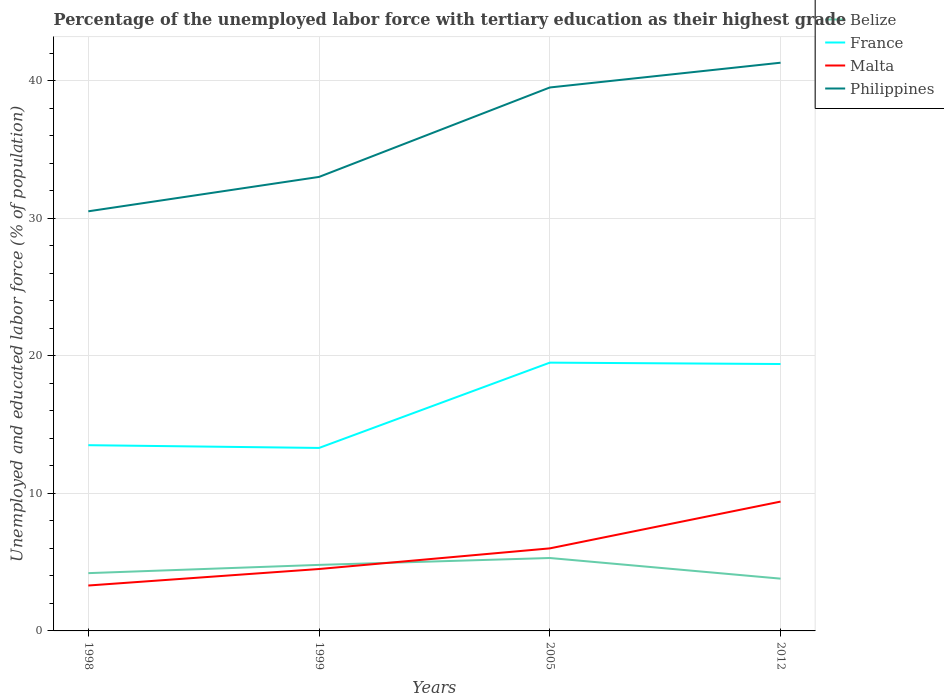Does the line corresponding to Malta intersect with the line corresponding to Belize?
Keep it short and to the point. Yes. Across all years, what is the maximum percentage of the unemployed labor force with tertiary education in Belize?
Ensure brevity in your answer.  3.8. What is the total percentage of the unemployed labor force with tertiary education in Malta in the graph?
Your response must be concise. -1.2. What is the difference between the highest and the second highest percentage of the unemployed labor force with tertiary education in Malta?
Ensure brevity in your answer.  6.1. What is the difference between the highest and the lowest percentage of the unemployed labor force with tertiary education in Philippines?
Provide a succinct answer. 2. How many years are there in the graph?
Give a very brief answer. 4. What is the difference between two consecutive major ticks on the Y-axis?
Your response must be concise. 10. Are the values on the major ticks of Y-axis written in scientific E-notation?
Offer a very short reply. No. Where does the legend appear in the graph?
Your answer should be compact. Top right. How many legend labels are there?
Ensure brevity in your answer.  4. What is the title of the graph?
Keep it short and to the point. Percentage of the unemployed labor force with tertiary education as their highest grade. What is the label or title of the X-axis?
Your answer should be very brief. Years. What is the label or title of the Y-axis?
Provide a succinct answer. Unemployed and educated labor force (% of population). What is the Unemployed and educated labor force (% of population) in Belize in 1998?
Provide a succinct answer. 4.2. What is the Unemployed and educated labor force (% of population) of France in 1998?
Your answer should be very brief. 13.5. What is the Unemployed and educated labor force (% of population) of Malta in 1998?
Keep it short and to the point. 3.3. What is the Unemployed and educated labor force (% of population) in Philippines in 1998?
Provide a short and direct response. 30.5. What is the Unemployed and educated labor force (% of population) in Belize in 1999?
Offer a very short reply. 4.8. What is the Unemployed and educated labor force (% of population) in France in 1999?
Keep it short and to the point. 13.3. What is the Unemployed and educated labor force (% of population) of Malta in 1999?
Your answer should be very brief. 4.5. What is the Unemployed and educated labor force (% of population) of Belize in 2005?
Keep it short and to the point. 5.3. What is the Unemployed and educated labor force (% of population) in Philippines in 2005?
Provide a succinct answer. 39.5. What is the Unemployed and educated labor force (% of population) of Belize in 2012?
Ensure brevity in your answer.  3.8. What is the Unemployed and educated labor force (% of population) of France in 2012?
Ensure brevity in your answer.  19.4. What is the Unemployed and educated labor force (% of population) in Malta in 2012?
Provide a short and direct response. 9.4. What is the Unemployed and educated labor force (% of population) of Philippines in 2012?
Ensure brevity in your answer.  41.3. Across all years, what is the maximum Unemployed and educated labor force (% of population) of Belize?
Provide a succinct answer. 5.3. Across all years, what is the maximum Unemployed and educated labor force (% of population) of France?
Give a very brief answer. 19.5. Across all years, what is the maximum Unemployed and educated labor force (% of population) in Malta?
Your response must be concise. 9.4. Across all years, what is the maximum Unemployed and educated labor force (% of population) in Philippines?
Offer a very short reply. 41.3. Across all years, what is the minimum Unemployed and educated labor force (% of population) in Belize?
Ensure brevity in your answer.  3.8. Across all years, what is the minimum Unemployed and educated labor force (% of population) of France?
Ensure brevity in your answer.  13.3. Across all years, what is the minimum Unemployed and educated labor force (% of population) in Malta?
Your response must be concise. 3.3. Across all years, what is the minimum Unemployed and educated labor force (% of population) of Philippines?
Offer a terse response. 30.5. What is the total Unemployed and educated labor force (% of population) of France in the graph?
Your answer should be very brief. 65.7. What is the total Unemployed and educated labor force (% of population) in Malta in the graph?
Ensure brevity in your answer.  23.2. What is the total Unemployed and educated labor force (% of population) in Philippines in the graph?
Your response must be concise. 144.3. What is the difference between the Unemployed and educated labor force (% of population) of France in 1998 and that in 1999?
Provide a succinct answer. 0.2. What is the difference between the Unemployed and educated labor force (% of population) of Belize in 1998 and that in 2005?
Keep it short and to the point. -1.1. What is the difference between the Unemployed and educated labor force (% of population) of France in 1998 and that in 2005?
Provide a short and direct response. -6. What is the difference between the Unemployed and educated labor force (% of population) of Philippines in 1998 and that in 2005?
Provide a succinct answer. -9. What is the difference between the Unemployed and educated labor force (% of population) of France in 1998 and that in 2012?
Offer a very short reply. -5.9. What is the difference between the Unemployed and educated labor force (% of population) in Belize in 1999 and that in 2005?
Give a very brief answer. -0.5. What is the difference between the Unemployed and educated labor force (% of population) of Malta in 1999 and that in 2005?
Offer a terse response. -1.5. What is the difference between the Unemployed and educated labor force (% of population) of Philippines in 1999 and that in 2005?
Your response must be concise. -6.5. What is the difference between the Unemployed and educated labor force (% of population) in France in 1999 and that in 2012?
Provide a succinct answer. -6.1. What is the difference between the Unemployed and educated labor force (% of population) in Belize in 2005 and that in 2012?
Your response must be concise. 1.5. What is the difference between the Unemployed and educated labor force (% of population) of France in 2005 and that in 2012?
Offer a very short reply. 0.1. What is the difference between the Unemployed and educated labor force (% of population) of Belize in 1998 and the Unemployed and educated labor force (% of population) of Philippines in 1999?
Your response must be concise. -28.8. What is the difference between the Unemployed and educated labor force (% of population) of France in 1998 and the Unemployed and educated labor force (% of population) of Philippines in 1999?
Ensure brevity in your answer.  -19.5. What is the difference between the Unemployed and educated labor force (% of population) of Malta in 1998 and the Unemployed and educated labor force (% of population) of Philippines in 1999?
Your answer should be very brief. -29.7. What is the difference between the Unemployed and educated labor force (% of population) of Belize in 1998 and the Unemployed and educated labor force (% of population) of France in 2005?
Your answer should be very brief. -15.3. What is the difference between the Unemployed and educated labor force (% of population) of Belize in 1998 and the Unemployed and educated labor force (% of population) of Philippines in 2005?
Give a very brief answer. -35.3. What is the difference between the Unemployed and educated labor force (% of population) in France in 1998 and the Unemployed and educated labor force (% of population) in Philippines in 2005?
Provide a short and direct response. -26. What is the difference between the Unemployed and educated labor force (% of population) in Malta in 1998 and the Unemployed and educated labor force (% of population) in Philippines in 2005?
Make the answer very short. -36.2. What is the difference between the Unemployed and educated labor force (% of population) in Belize in 1998 and the Unemployed and educated labor force (% of population) in France in 2012?
Offer a terse response. -15.2. What is the difference between the Unemployed and educated labor force (% of population) in Belize in 1998 and the Unemployed and educated labor force (% of population) in Philippines in 2012?
Provide a short and direct response. -37.1. What is the difference between the Unemployed and educated labor force (% of population) of France in 1998 and the Unemployed and educated labor force (% of population) of Malta in 2012?
Provide a short and direct response. 4.1. What is the difference between the Unemployed and educated labor force (% of population) in France in 1998 and the Unemployed and educated labor force (% of population) in Philippines in 2012?
Offer a very short reply. -27.8. What is the difference between the Unemployed and educated labor force (% of population) in Malta in 1998 and the Unemployed and educated labor force (% of population) in Philippines in 2012?
Ensure brevity in your answer.  -38. What is the difference between the Unemployed and educated labor force (% of population) in Belize in 1999 and the Unemployed and educated labor force (% of population) in France in 2005?
Your response must be concise. -14.7. What is the difference between the Unemployed and educated labor force (% of population) in Belize in 1999 and the Unemployed and educated labor force (% of population) in Malta in 2005?
Offer a terse response. -1.2. What is the difference between the Unemployed and educated labor force (% of population) of Belize in 1999 and the Unemployed and educated labor force (% of population) of Philippines in 2005?
Ensure brevity in your answer.  -34.7. What is the difference between the Unemployed and educated labor force (% of population) in France in 1999 and the Unemployed and educated labor force (% of population) in Philippines in 2005?
Offer a very short reply. -26.2. What is the difference between the Unemployed and educated labor force (% of population) of Malta in 1999 and the Unemployed and educated labor force (% of population) of Philippines in 2005?
Make the answer very short. -35. What is the difference between the Unemployed and educated labor force (% of population) of Belize in 1999 and the Unemployed and educated labor force (% of population) of France in 2012?
Make the answer very short. -14.6. What is the difference between the Unemployed and educated labor force (% of population) of Belize in 1999 and the Unemployed and educated labor force (% of population) of Malta in 2012?
Offer a terse response. -4.6. What is the difference between the Unemployed and educated labor force (% of population) in Belize in 1999 and the Unemployed and educated labor force (% of population) in Philippines in 2012?
Make the answer very short. -36.5. What is the difference between the Unemployed and educated labor force (% of population) of France in 1999 and the Unemployed and educated labor force (% of population) of Philippines in 2012?
Give a very brief answer. -28. What is the difference between the Unemployed and educated labor force (% of population) in Malta in 1999 and the Unemployed and educated labor force (% of population) in Philippines in 2012?
Keep it short and to the point. -36.8. What is the difference between the Unemployed and educated labor force (% of population) of Belize in 2005 and the Unemployed and educated labor force (% of population) of France in 2012?
Offer a terse response. -14.1. What is the difference between the Unemployed and educated labor force (% of population) of Belize in 2005 and the Unemployed and educated labor force (% of population) of Philippines in 2012?
Ensure brevity in your answer.  -36. What is the difference between the Unemployed and educated labor force (% of population) of France in 2005 and the Unemployed and educated labor force (% of population) of Malta in 2012?
Make the answer very short. 10.1. What is the difference between the Unemployed and educated labor force (% of population) in France in 2005 and the Unemployed and educated labor force (% of population) in Philippines in 2012?
Offer a very short reply. -21.8. What is the difference between the Unemployed and educated labor force (% of population) in Malta in 2005 and the Unemployed and educated labor force (% of population) in Philippines in 2012?
Ensure brevity in your answer.  -35.3. What is the average Unemployed and educated labor force (% of population) in Belize per year?
Offer a terse response. 4.53. What is the average Unemployed and educated labor force (% of population) in France per year?
Give a very brief answer. 16.43. What is the average Unemployed and educated labor force (% of population) of Malta per year?
Make the answer very short. 5.8. What is the average Unemployed and educated labor force (% of population) of Philippines per year?
Give a very brief answer. 36.08. In the year 1998, what is the difference between the Unemployed and educated labor force (% of population) in Belize and Unemployed and educated labor force (% of population) in Malta?
Keep it short and to the point. 0.9. In the year 1998, what is the difference between the Unemployed and educated labor force (% of population) in Belize and Unemployed and educated labor force (% of population) in Philippines?
Offer a very short reply. -26.3. In the year 1998, what is the difference between the Unemployed and educated labor force (% of population) in France and Unemployed and educated labor force (% of population) in Malta?
Ensure brevity in your answer.  10.2. In the year 1998, what is the difference between the Unemployed and educated labor force (% of population) of France and Unemployed and educated labor force (% of population) of Philippines?
Offer a very short reply. -17. In the year 1998, what is the difference between the Unemployed and educated labor force (% of population) in Malta and Unemployed and educated labor force (% of population) in Philippines?
Ensure brevity in your answer.  -27.2. In the year 1999, what is the difference between the Unemployed and educated labor force (% of population) in Belize and Unemployed and educated labor force (% of population) in France?
Ensure brevity in your answer.  -8.5. In the year 1999, what is the difference between the Unemployed and educated labor force (% of population) of Belize and Unemployed and educated labor force (% of population) of Philippines?
Your answer should be compact. -28.2. In the year 1999, what is the difference between the Unemployed and educated labor force (% of population) of France and Unemployed and educated labor force (% of population) of Philippines?
Make the answer very short. -19.7. In the year 1999, what is the difference between the Unemployed and educated labor force (% of population) in Malta and Unemployed and educated labor force (% of population) in Philippines?
Provide a short and direct response. -28.5. In the year 2005, what is the difference between the Unemployed and educated labor force (% of population) in Belize and Unemployed and educated labor force (% of population) in Malta?
Give a very brief answer. -0.7. In the year 2005, what is the difference between the Unemployed and educated labor force (% of population) in Belize and Unemployed and educated labor force (% of population) in Philippines?
Your response must be concise. -34.2. In the year 2005, what is the difference between the Unemployed and educated labor force (% of population) in France and Unemployed and educated labor force (% of population) in Philippines?
Your answer should be very brief. -20. In the year 2005, what is the difference between the Unemployed and educated labor force (% of population) in Malta and Unemployed and educated labor force (% of population) in Philippines?
Your answer should be compact. -33.5. In the year 2012, what is the difference between the Unemployed and educated labor force (% of population) in Belize and Unemployed and educated labor force (% of population) in France?
Offer a terse response. -15.6. In the year 2012, what is the difference between the Unemployed and educated labor force (% of population) of Belize and Unemployed and educated labor force (% of population) of Philippines?
Keep it short and to the point. -37.5. In the year 2012, what is the difference between the Unemployed and educated labor force (% of population) in France and Unemployed and educated labor force (% of population) in Malta?
Your answer should be very brief. 10. In the year 2012, what is the difference between the Unemployed and educated labor force (% of population) in France and Unemployed and educated labor force (% of population) in Philippines?
Offer a very short reply. -21.9. In the year 2012, what is the difference between the Unemployed and educated labor force (% of population) in Malta and Unemployed and educated labor force (% of population) in Philippines?
Offer a terse response. -31.9. What is the ratio of the Unemployed and educated labor force (% of population) in France in 1998 to that in 1999?
Your response must be concise. 1.01. What is the ratio of the Unemployed and educated labor force (% of population) in Malta in 1998 to that in 1999?
Make the answer very short. 0.73. What is the ratio of the Unemployed and educated labor force (% of population) in Philippines in 1998 to that in 1999?
Your answer should be very brief. 0.92. What is the ratio of the Unemployed and educated labor force (% of population) of Belize in 1998 to that in 2005?
Make the answer very short. 0.79. What is the ratio of the Unemployed and educated labor force (% of population) of France in 1998 to that in 2005?
Provide a short and direct response. 0.69. What is the ratio of the Unemployed and educated labor force (% of population) of Malta in 1998 to that in 2005?
Your answer should be compact. 0.55. What is the ratio of the Unemployed and educated labor force (% of population) of Philippines in 1998 to that in 2005?
Keep it short and to the point. 0.77. What is the ratio of the Unemployed and educated labor force (% of population) in Belize in 1998 to that in 2012?
Keep it short and to the point. 1.11. What is the ratio of the Unemployed and educated labor force (% of population) of France in 1998 to that in 2012?
Provide a succinct answer. 0.7. What is the ratio of the Unemployed and educated labor force (% of population) in Malta in 1998 to that in 2012?
Your answer should be very brief. 0.35. What is the ratio of the Unemployed and educated labor force (% of population) in Philippines in 1998 to that in 2012?
Offer a very short reply. 0.74. What is the ratio of the Unemployed and educated labor force (% of population) in Belize in 1999 to that in 2005?
Give a very brief answer. 0.91. What is the ratio of the Unemployed and educated labor force (% of population) of France in 1999 to that in 2005?
Ensure brevity in your answer.  0.68. What is the ratio of the Unemployed and educated labor force (% of population) of Philippines in 1999 to that in 2005?
Your response must be concise. 0.84. What is the ratio of the Unemployed and educated labor force (% of population) in Belize in 1999 to that in 2012?
Your answer should be very brief. 1.26. What is the ratio of the Unemployed and educated labor force (% of population) in France in 1999 to that in 2012?
Keep it short and to the point. 0.69. What is the ratio of the Unemployed and educated labor force (% of population) in Malta in 1999 to that in 2012?
Give a very brief answer. 0.48. What is the ratio of the Unemployed and educated labor force (% of population) in Philippines in 1999 to that in 2012?
Your answer should be very brief. 0.8. What is the ratio of the Unemployed and educated labor force (% of population) of Belize in 2005 to that in 2012?
Provide a succinct answer. 1.39. What is the ratio of the Unemployed and educated labor force (% of population) of Malta in 2005 to that in 2012?
Ensure brevity in your answer.  0.64. What is the ratio of the Unemployed and educated labor force (% of population) of Philippines in 2005 to that in 2012?
Make the answer very short. 0.96. What is the difference between the highest and the lowest Unemployed and educated labor force (% of population) of Belize?
Offer a very short reply. 1.5. 